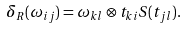Convert formula to latex. <formula><loc_0><loc_0><loc_500><loc_500>\delta _ { R } ( \omega _ { i j } ) = \omega _ { k l } \otimes t _ { k i } S ( t _ { j l } ) .</formula> 